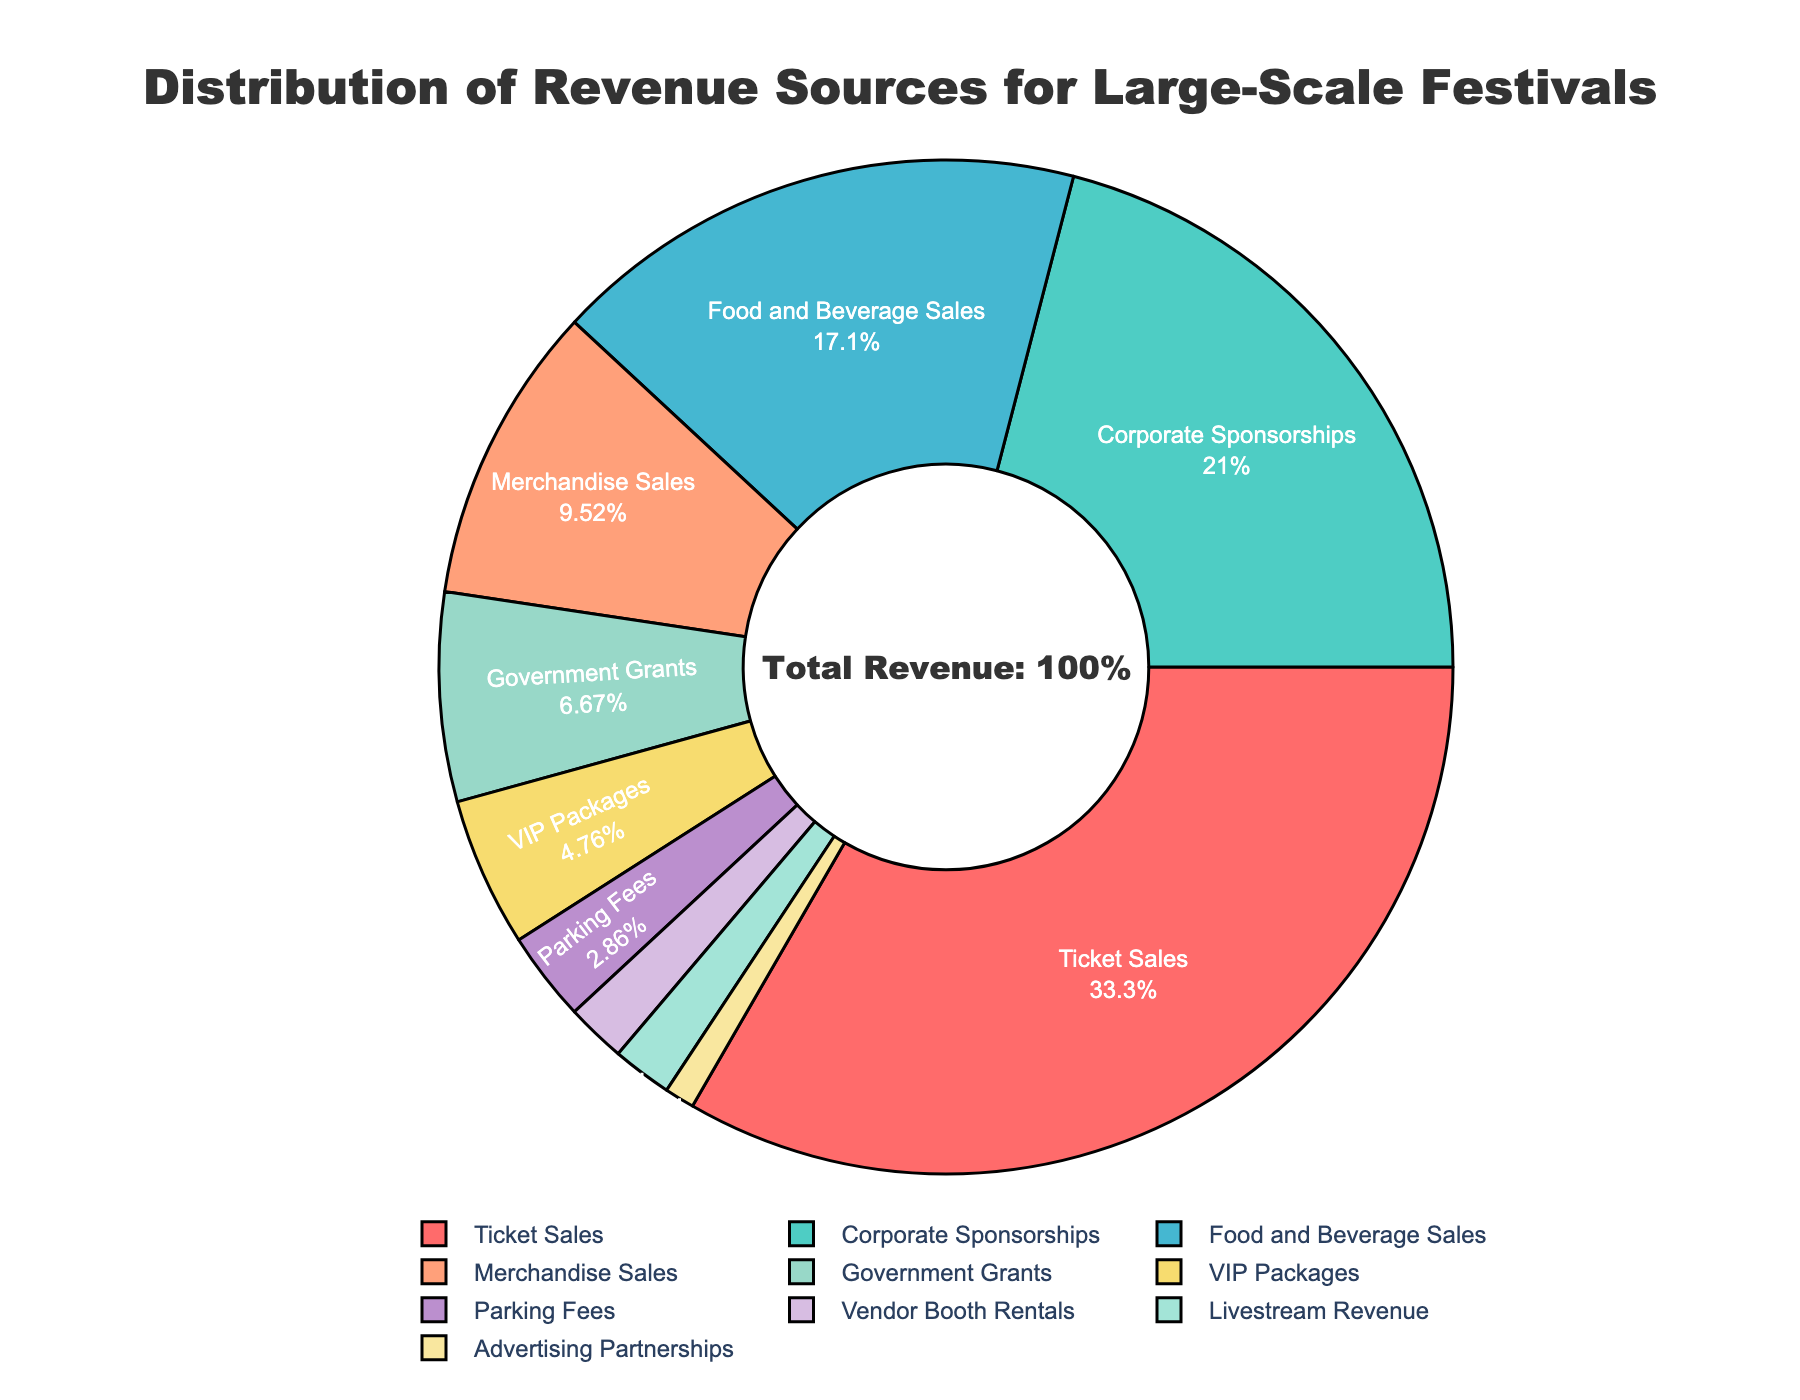What percentage of revenue comes from Ticket Sales and Corporate Sponsorships combined? Ticket Sales contribute 35% and Corporate Sponsorships contribute 22%. Adding these together gives 35% + 22% = 57%.
Answer: 57% Which revenue source contributes the least to the total revenue? By examining the figure, the smallest portion is attributed to Advertising Partnerships, which accounts for 1% of the total revenue.
Answer: Advertising Partnerships Is the revenue from Food and Beverage Sales greater than Merchandise Sales? The revenue from Food and Beverage Sales is 18%, while Merchandise Sales is 10%. Since 18% is greater than 10%, the revenue from Food and Beverage Sales is indeed greater.
Answer: Yes What is the difference in revenue contribution between VIP Packages and Parking Fees? VIP Packages contribute 5% and Parking Fees contribute 3%. The difference is 5% - 3% = 2%.
Answer: 2% How does the combined revenue from Vendor Booth Rentals and Livestream Revenue compare to Parking Fees? Vendor Booth Rentals contribute 2% and Livestream Revenue also contributes 2%. Combined, they sum to 2% + 2% = 4%. Parking Fees contribute 3%. Thus, 4% is greater than 3%.
Answer: Greater Which revenue source has a larger contributing percentage, Government Grants or Merchandise Sales? Government Grants contribute 7%, while Merchandise Sales contribute 10%. Since 10% is greater than 7%, Merchandise Sales have a larger percentage.
Answer: Merchandise Sales Among the non-ticket revenue sources, which one contributes the most? Excluding Ticket Sales, the highest contribution comes from Corporate Sponsorships at 22%.
Answer: Corporate Sponsorships What is the combined revenue percentage from Ticket Sales, VIP Packages, and Advertising Partnerships? Ticket Sales contribute 35%, VIP Packages contribute 5%, and Advertising Partnerships contribute 1%. Adding them gives 35% + 5% + 1% = 41%.
Answer: 41% How many revenue sources have a contribution greater than 10% each? Examining the figure, Ticket Sales (35%), Corporate Sponsorships (22%), and Food and Beverage Sales (18%) each have contributions greater than 10%. There are 3 such revenue sources.
Answer: 3 What color is used to represent Merchandise Sales in the pie chart? By examining the color of the section labeled "Merchandise Sales," it is represented with a light pink shade.
Answer: Light pink 